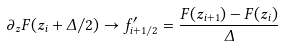Convert formula to latex. <formula><loc_0><loc_0><loc_500><loc_500>\partial _ { z } F ( z _ { i } + \Delta / 2 ) \rightarrow f ^ { \prime } _ { i + 1 / 2 } = \frac { F ( z _ { i + 1 } ) - F ( z _ { i } ) } { \Delta }</formula> 